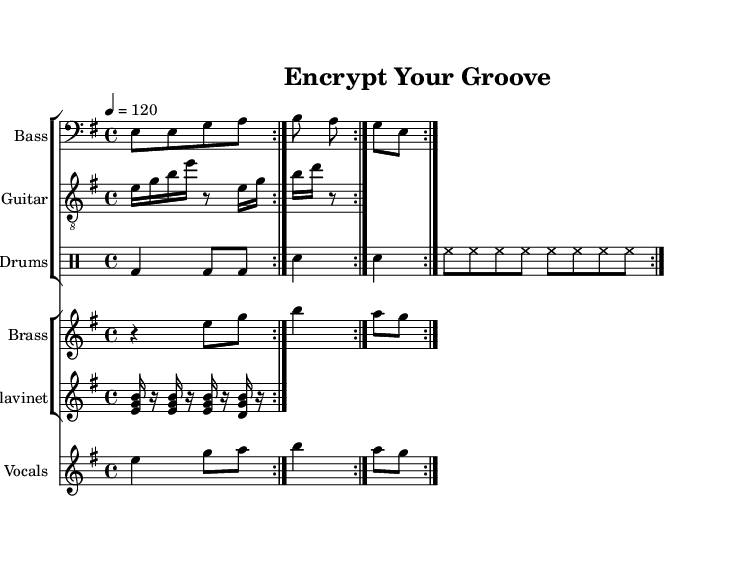What is the key signature of this music? The key signature indicated on the staff shows two sharps, which signifies that the music is in E minor.
Answer: E minor What is the time signature of this music? The time signature displayed is four over four, denoted by the fraction 4/4. This indicates there are four beats in each measure.
Answer: 4/4 What is the tempo marking of this piece? The tempo marking is indicated as 4 equals 120, which means there should be 120 beats per minute.
Answer: 120 How many measures does the bass line repeat? The bass line is written with a repeat sign (volta 2), indicating that it should be played twice before moving on.
Answer: 2 What instruments are included in this composition? The score features five instruments: Bass, Guitar, Drums, Brass, Clavinet, and Vocals. This variety is typical of funk music.
Answer: Bass, Guitar, Drums, Brass, Clavinet, Vocals Which section contains chords typically associated with funk music? The Clavinet section plays chords that provide that distinctive funky sound, contrasting the melody lines.
Answer: Clavinet What rhythmic pattern is predominant in the drum section? The drum section features a consistent bass and snare pattern, with hi-hat eighth notes creating a steady groove. This is a fundamental aspect of funk drumming.
Answer: Steady groove 